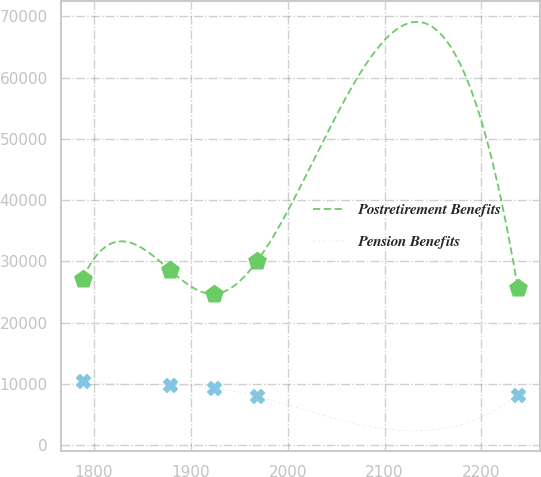<chart> <loc_0><loc_0><loc_500><loc_500><line_chart><ecel><fcel>Postretirement Benefits<fcel>Pension Benefits<nl><fcel>1788.37<fcel>27216.5<fcel>10526.2<nl><fcel>1878.77<fcel>28559.6<fcel>9869.83<nl><fcel>1923.68<fcel>24685.3<fcel>9397.94<nl><fcel>1968.59<fcel>30088.1<fcel>7975.49<nl><fcel>2237.51<fcel>25640.9<fcel>8230.57<nl></chart> 